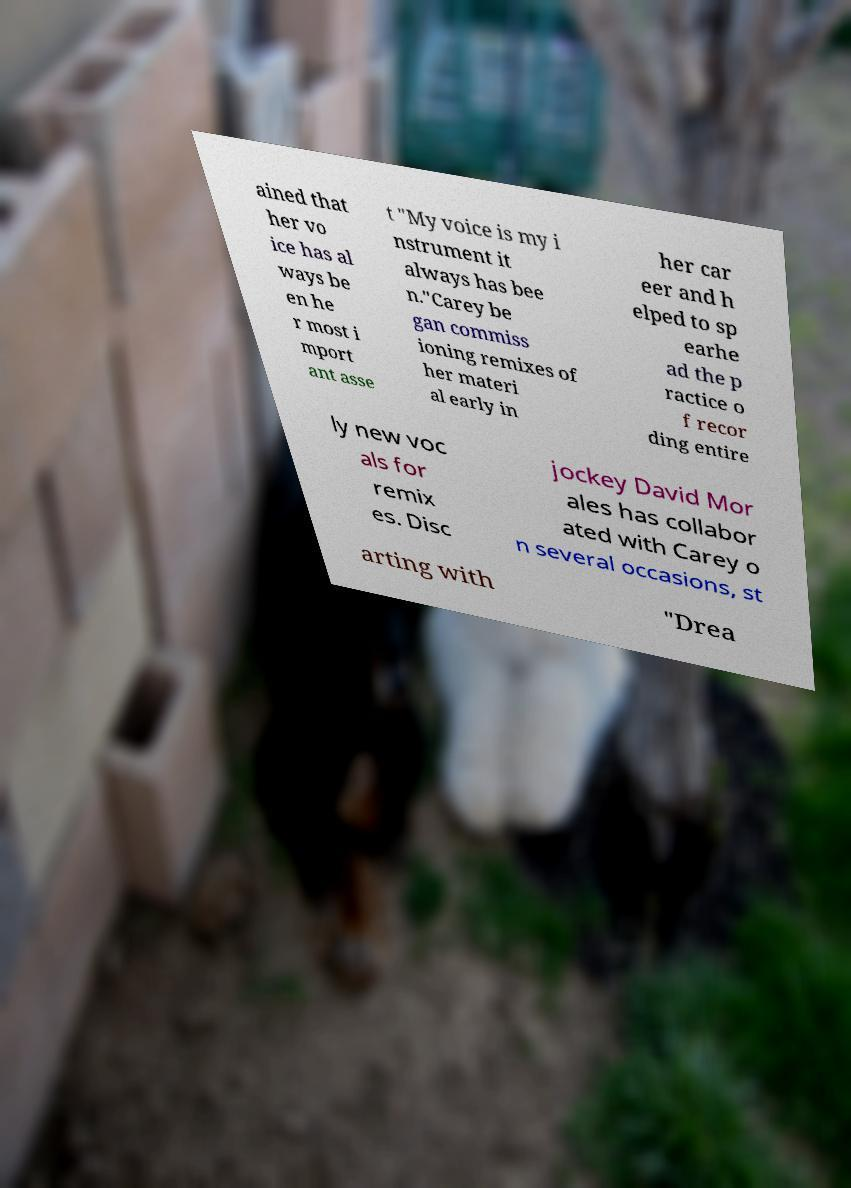I need the written content from this picture converted into text. Can you do that? ained that her vo ice has al ways be en he r most i mport ant asse t "My voice is my i nstrument it always has bee n."Carey be gan commiss ioning remixes of her materi al early in her car eer and h elped to sp earhe ad the p ractice o f recor ding entire ly new voc als for remix es. Disc jockey David Mor ales has collabor ated with Carey o n several occasions, st arting with "Drea 